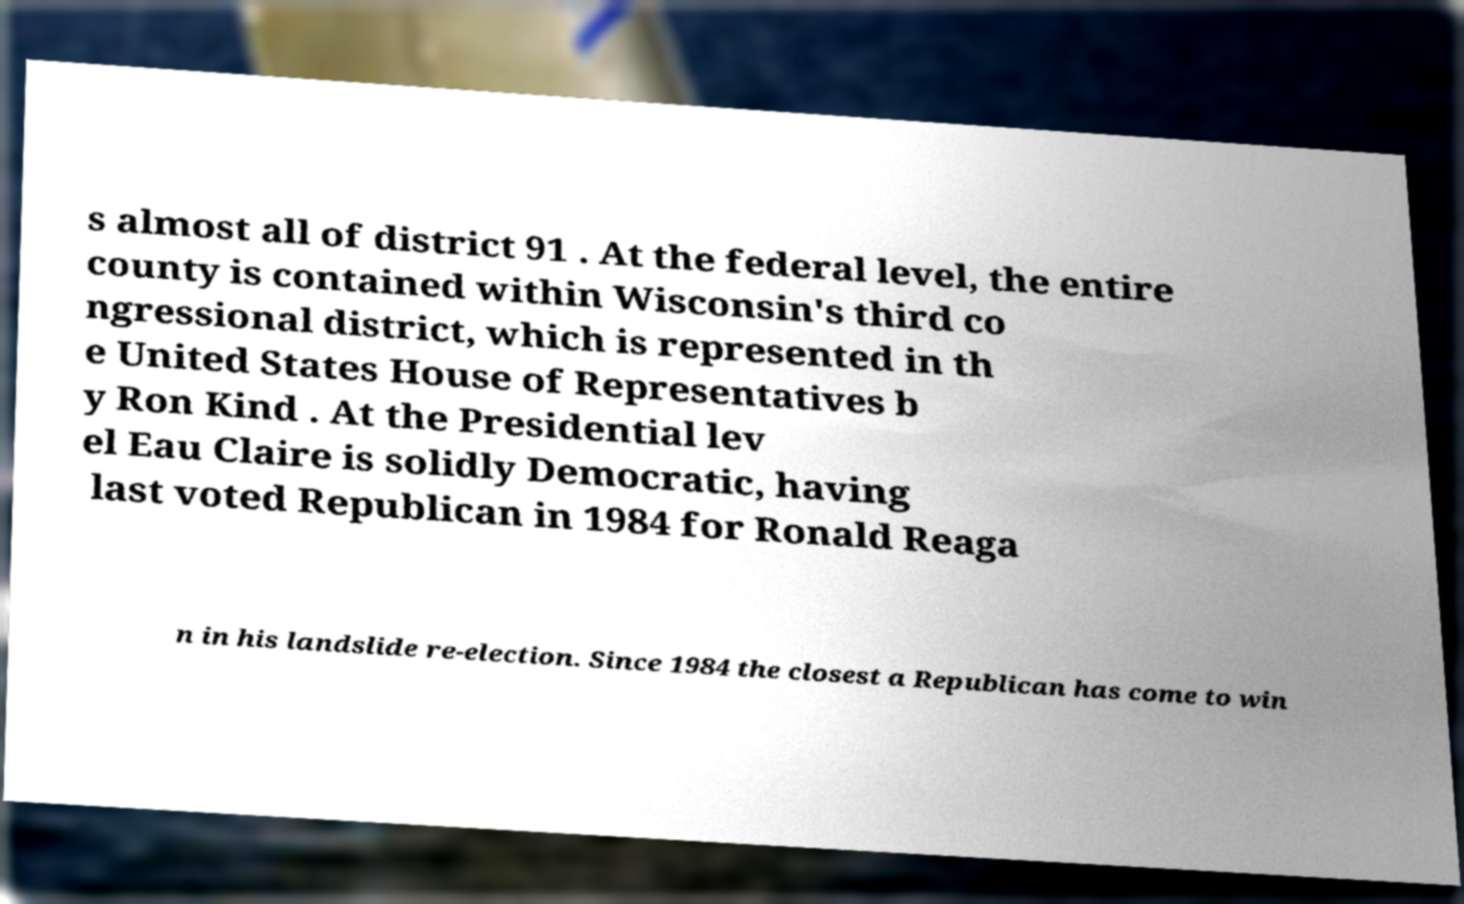There's text embedded in this image that I need extracted. Can you transcribe it verbatim? s almost all of district 91 . At the federal level, the entire county is contained within Wisconsin's third co ngressional district, which is represented in th e United States House of Representatives b y Ron Kind . At the Presidential lev el Eau Claire is solidly Democratic, having last voted Republican in 1984 for Ronald Reaga n in his landslide re-election. Since 1984 the closest a Republican has come to win 